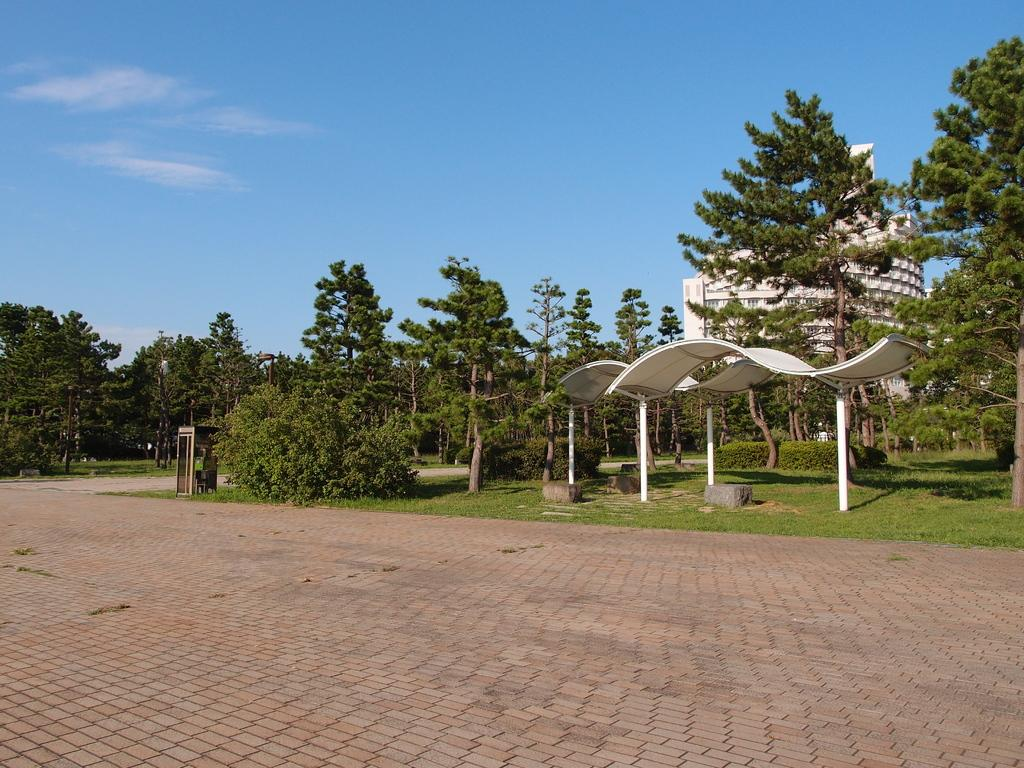What type of vegetation can be seen in the image? There are trees, plants, and grass visible in the image. What other objects can be seen in the image? There are stones, sheds, and a building visible in the image. What is visible in the background of the image? The sky with clouds is visible in the background of the image. What type of care can be seen being given to the clover in the image? There is no clover present in the image, so no care can be observed. 